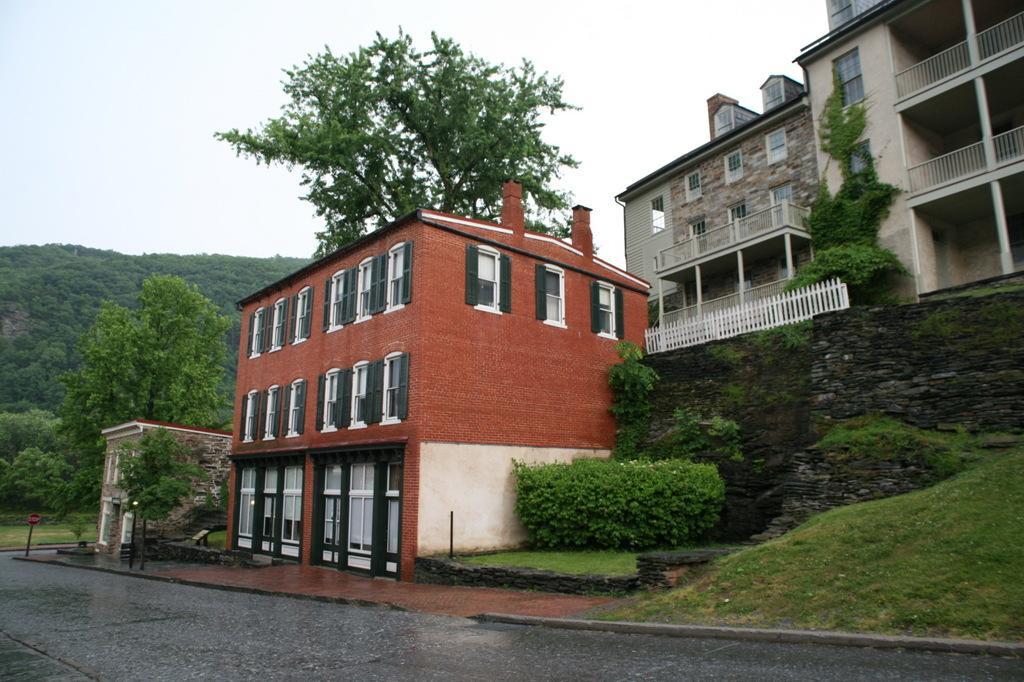How would you summarize this image in a sentence or two? In this picture we can see the road, trees, buildings with windows and in the background we can see the sky. 